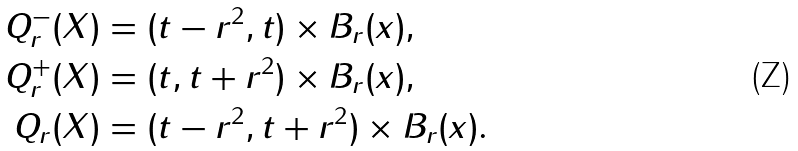Convert formula to latex. <formula><loc_0><loc_0><loc_500><loc_500>Q ^ { - } _ { r } ( X ) & = ( t - r ^ { 2 } , t ) \times B _ { r } ( x ) , \\ Q ^ { + } _ { r } ( X ) & = ( t , t + r ^ { 2 } ) \times B _ { r } ( x ) , \\ Q _ { r } ( X ) & = ( t - r ^ { 2 } , t + r ^ { 2 } ) \times B _ { r } ( x ) .</formula> 